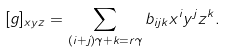Convert formula to latex. <formula><loc_0><loc_0><loc_500><loc_500>[ g ] _ { x y z } = \sum _ { ( i + j ) \gamma + k = r \gamma } b _ { i j k } x ^ { i } y ^ { j } z ^ { k } .</formula> 